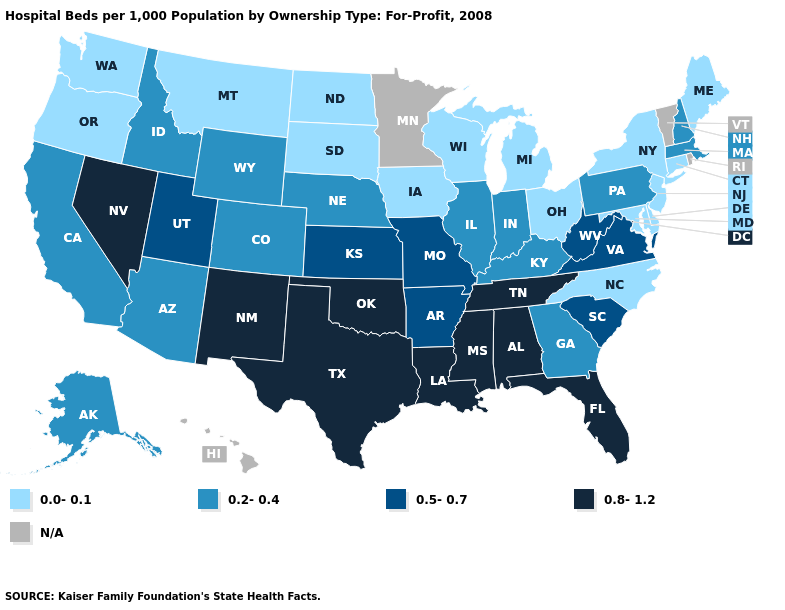Among the states that border Georgia , does North Carolina have the lowest value?
Give a very brief answer. Yes. Among the states that border Maine , which have the highest value?
Quick response, please. New Hampshire. Which states have the highest value in the USA?
Write a very short answer. Alabama, Florida, Louisiana, Mississippi, Nevada, New Mexico, Oklahoma, Tennessee, Texas. Which states have the highest value in the USA?
Concise answer only. Alabama, Florida, Louisiana, Mississippi, Nevada, New Mexico, Oklahoma, Tennessee, Texas. Name the states that have a value in the range 0.0-0.1?
Write a very short answer. Connecticut, Delaware, Iowa, Maine, Maryland, Michigan, Montana, New Jersey, New York, North Carolina, North Dakota, Ohio, Oregon, South Dakota, Washington, Wisconsin. Which states have the highest value in the USA?
Give a very brief answer. Alabama, Florida, Louisiana, Mississippi, Nevada, New Mexico, Oklahoma, Tennessee, Texas. Name the states that have a value in the range 0.2-0.4?
Concise answer only. Alaska, Arizona, California, Colorado, Georgia, Idaho, Illinois, Indiana, Kentucky, Massachusetts, Nebraska, New Hampshire, Pennsylvania, Wyoming. Among the states that border Pennsylvania , which have the highest value?
Keep it brief. West Virginia. Does Louisiana have the highest value in the South?
Concise answer only. Yes. Name the states that have a value in the range N/A?
Be succinct. Hawaii, Minnesota, Rhode Island, Vermont. What is the value of Georgia?
Give a very brief answer. 0.2-0.4. Which states have the highest value in the USA?
Give a very brief answer. Alabama, Florida, Louisiana, Mississippi, Nevada, New Mexico, Oklahoma, Tennessee, Texas. Is the legend a continuous bar?
Quick response, please. No. Name the states that have a value in the range 0.8-1.2?
Answer briefly. Alabama, Florida, Louisiana, Mississippi, Nevada, New Mexico, Oklahoma, Tennessee, Texas. 